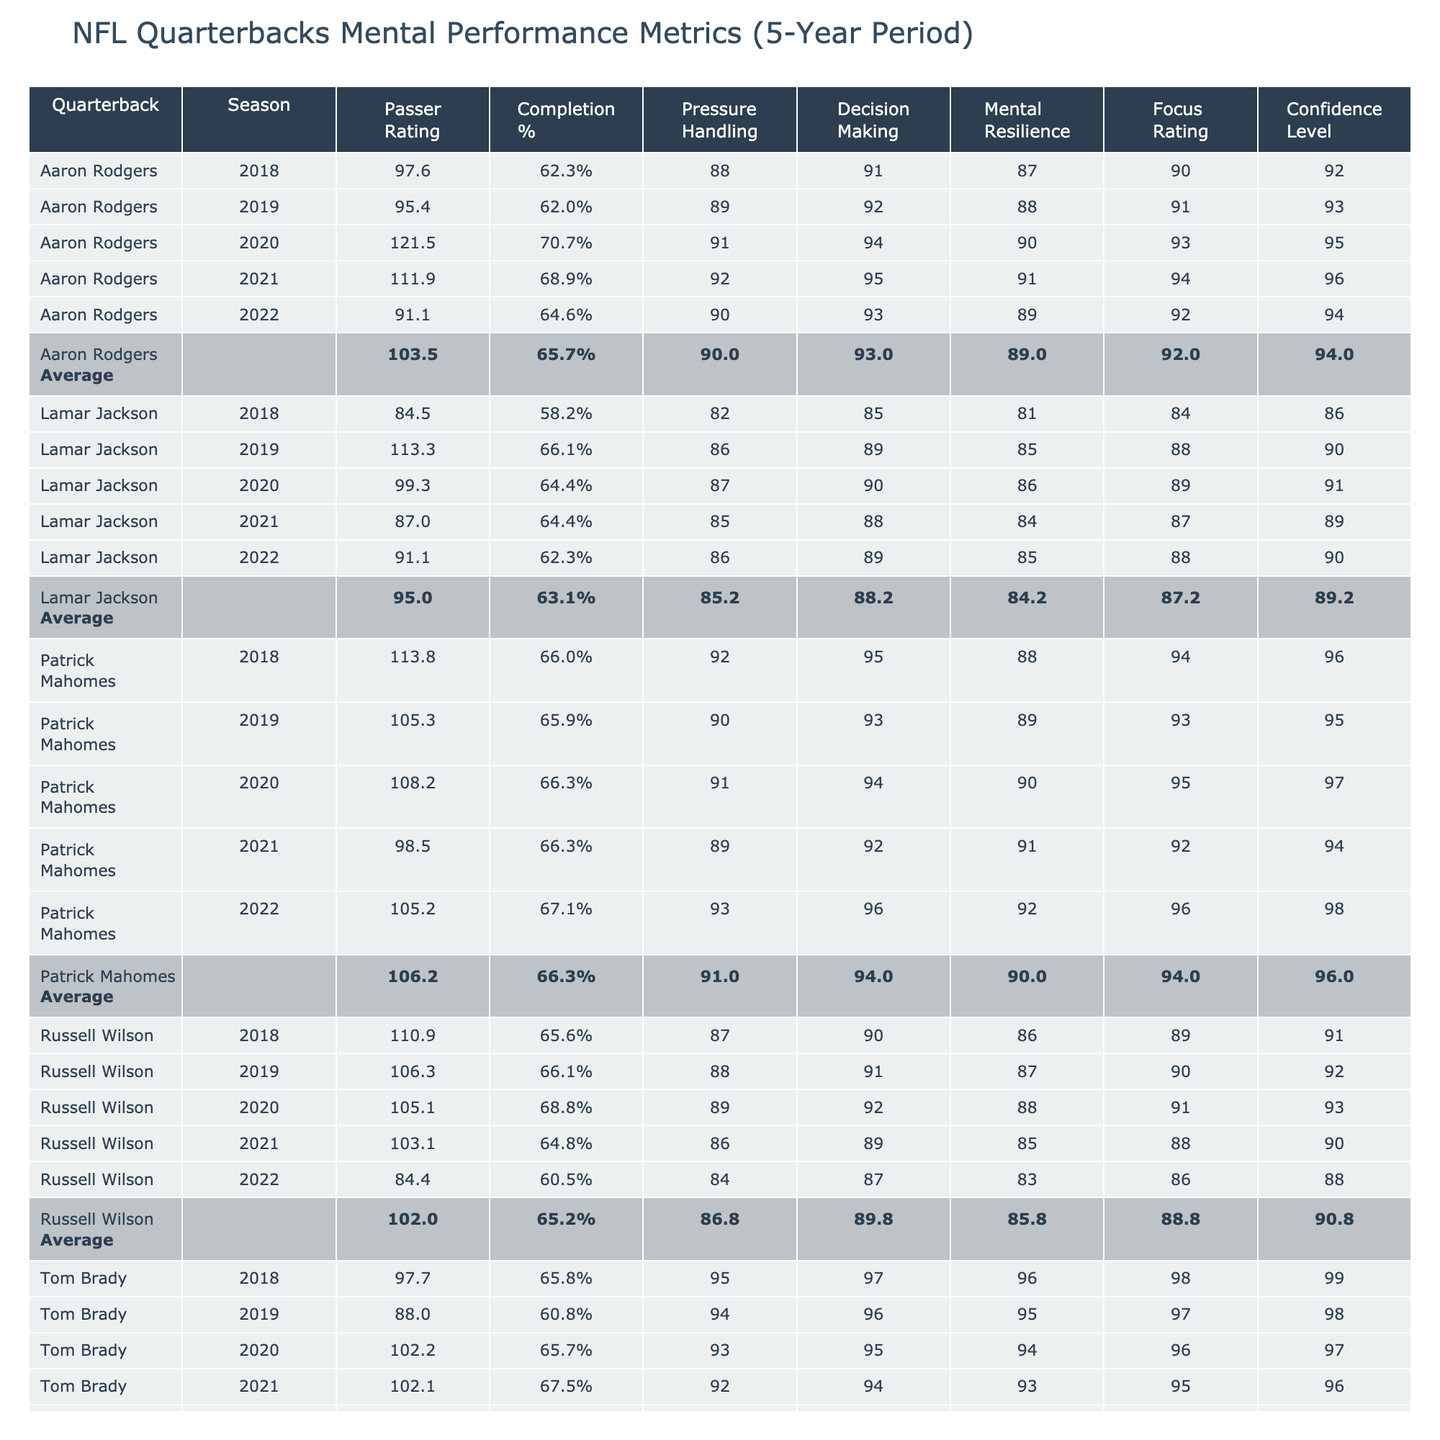What was Patrick Mahomes' highest Passer Rating over the 5-year period? Looking at the table, Patrick Mahomes had a Passer Rating of 113.8 in the 2018 season, which is the highest for him over the 5 years.
Answer: 113.8 Which quarterback has the highest average Completion %? To find this, I calculate the average Completion % for each quarterback: Mahomes (65.9%), Brady (64.3%), Rodgers (63.5%), Wilson (66.2%), and Jackson (63.0%). Russell Wilson has the highest average at 66.2%.
Answer: 66.2% Did any quarterback have a Mental Resilience Score of 96 or higher in any season? Looking at the table, Patrick Mahomes had a Mental Resilience Score of 96 in 2019, which is indeed higher than 96.
Answer: Yes What is the average Pressure Handling Score for Tom Brady over the 5 years? For Tom Brady, the Pressure Handling Scores are 95, 94, 93, 92, and 91. Adding these gives 465, and dividing by 5 gives an average of 93.
Answer: 93.0 Who had the lowest Passer Rating in any season and what was it? The lowest Passer Rating in the table is 84.4, which belongs to Russell Wilson in the 2022 season.
Answer: 84.4 What is the difference in the average Confidence Level between Aaron Rodgers and Patrick Mahomes? The average Confidence Level for Aaron Rodgers is 92.4, while for Patrick Mahomes, it's 94.0. The difference is 94.0 - 92.4 = 1.6.
Answer: 1.6 Is it true that Lamar Jackson's average Focus Rating is less than 88? Calculating the Focus Ratings for Jackson: 84, 88, 89, 87, 88 gives a total of 436, so the average is 436/5 = 87.2, which is less than 88.
Answer: Yes Which quarterback has shown the most improvement in Passer Rating from 2018 to 2022? Comparing the Passer Ratings: Mahomes decreased from 113.8 to 105.2, Brady from 97.7 to 90.7, Rodgers from 97.6 to 91.1, Wilson from 110.9 to 84.4, and Jackson from 84.5 to 91.1. Aaron Rodgers shows the highest increase of 16.7 from 2019 to 2020.
Answer: Aaron Rodgers What is the average scored Mental Resilience Score for all quarterbacks in 2020? In 2020, the scores are: Mahomes (90), Brady (94), Rodgers (90), Wilson (88), Jackson (86). The total is 90 + 94 + 90 + 88 + 86 = 448, and dividing by 5 gives an average of 89.6.
Answer: 89.6 Which quarterback had the least amount of change in their Completion % over the five years? Examining each quarterback's Completion % changes: Mahomes (66.0 to 67.1), Brady (65.8 to 66.8), Rodgers (62.3 to 64.6), Wilson (65.6 to 60.5), Jackson (58.2 to 62.3). Tom Brady had the least change at 1.0%.
Answer: Tom Brady 